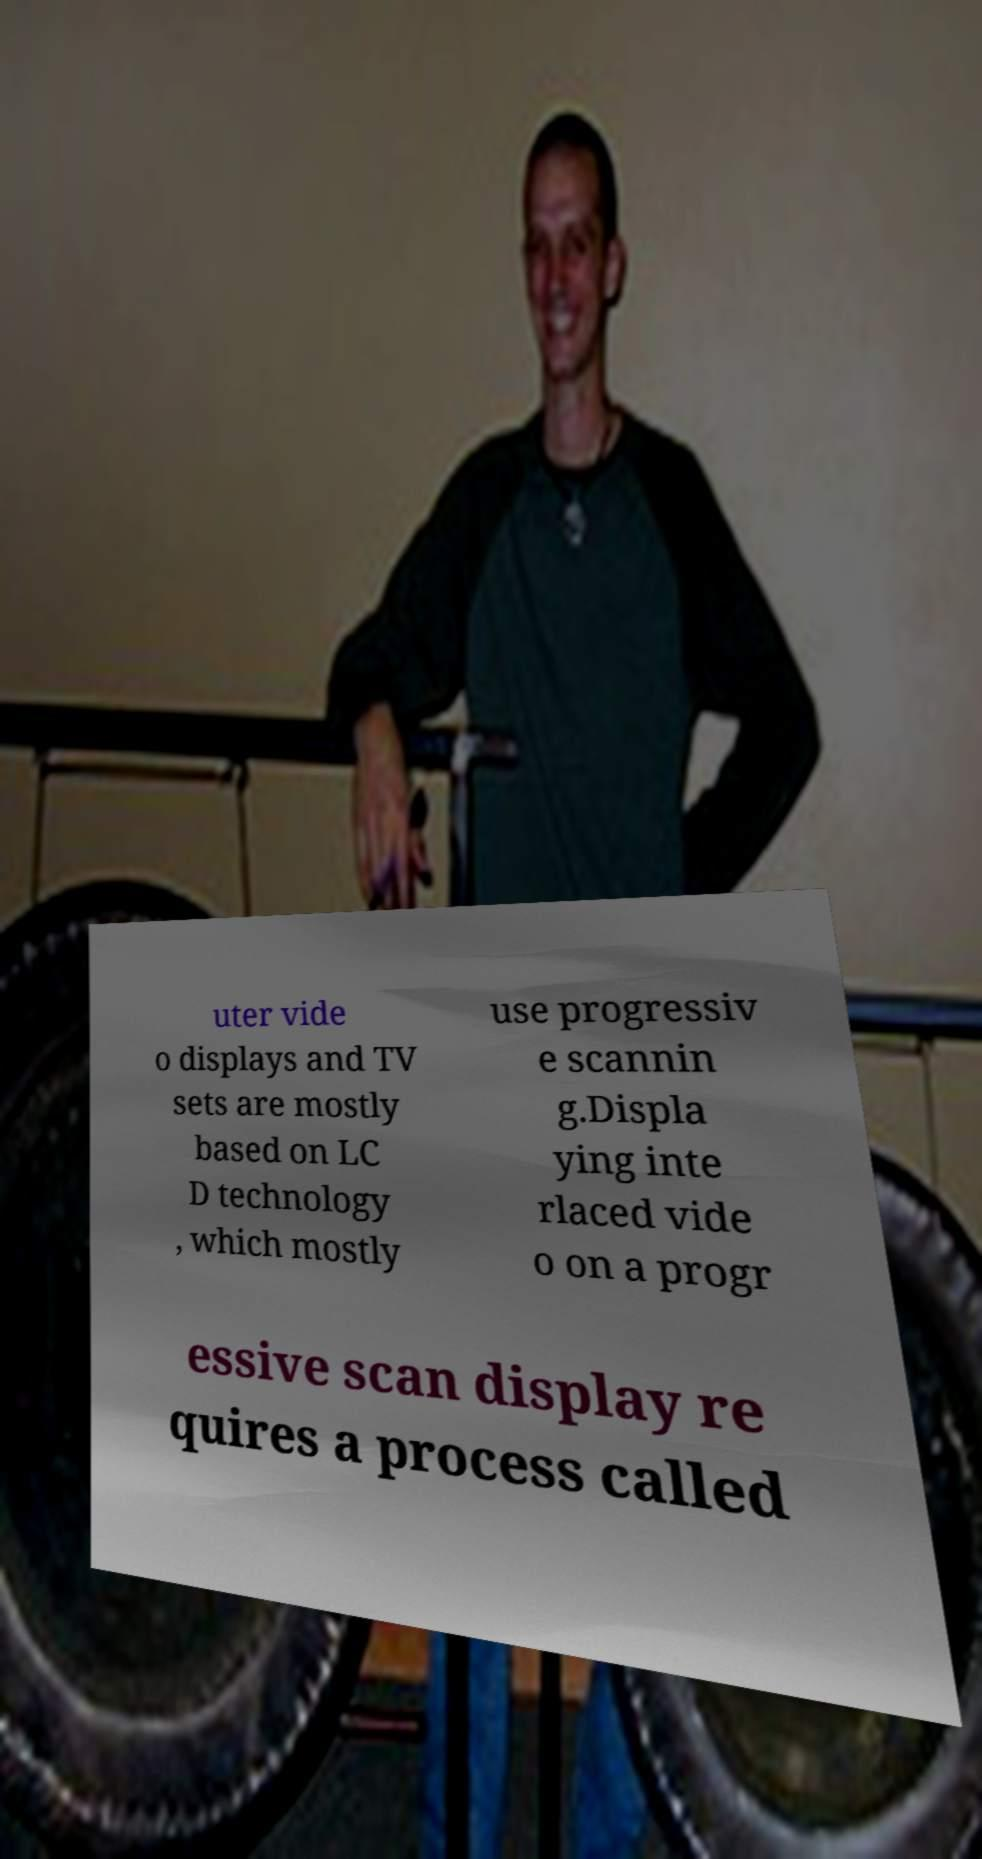Please identify and transcribe the text found in this image. uter vide o displays and TV sets are mostly based on LC D technology , which mostly use progressiv e scannin g.Displa ying inte rlaced vide o on a progr essive scan display re quires a process called 